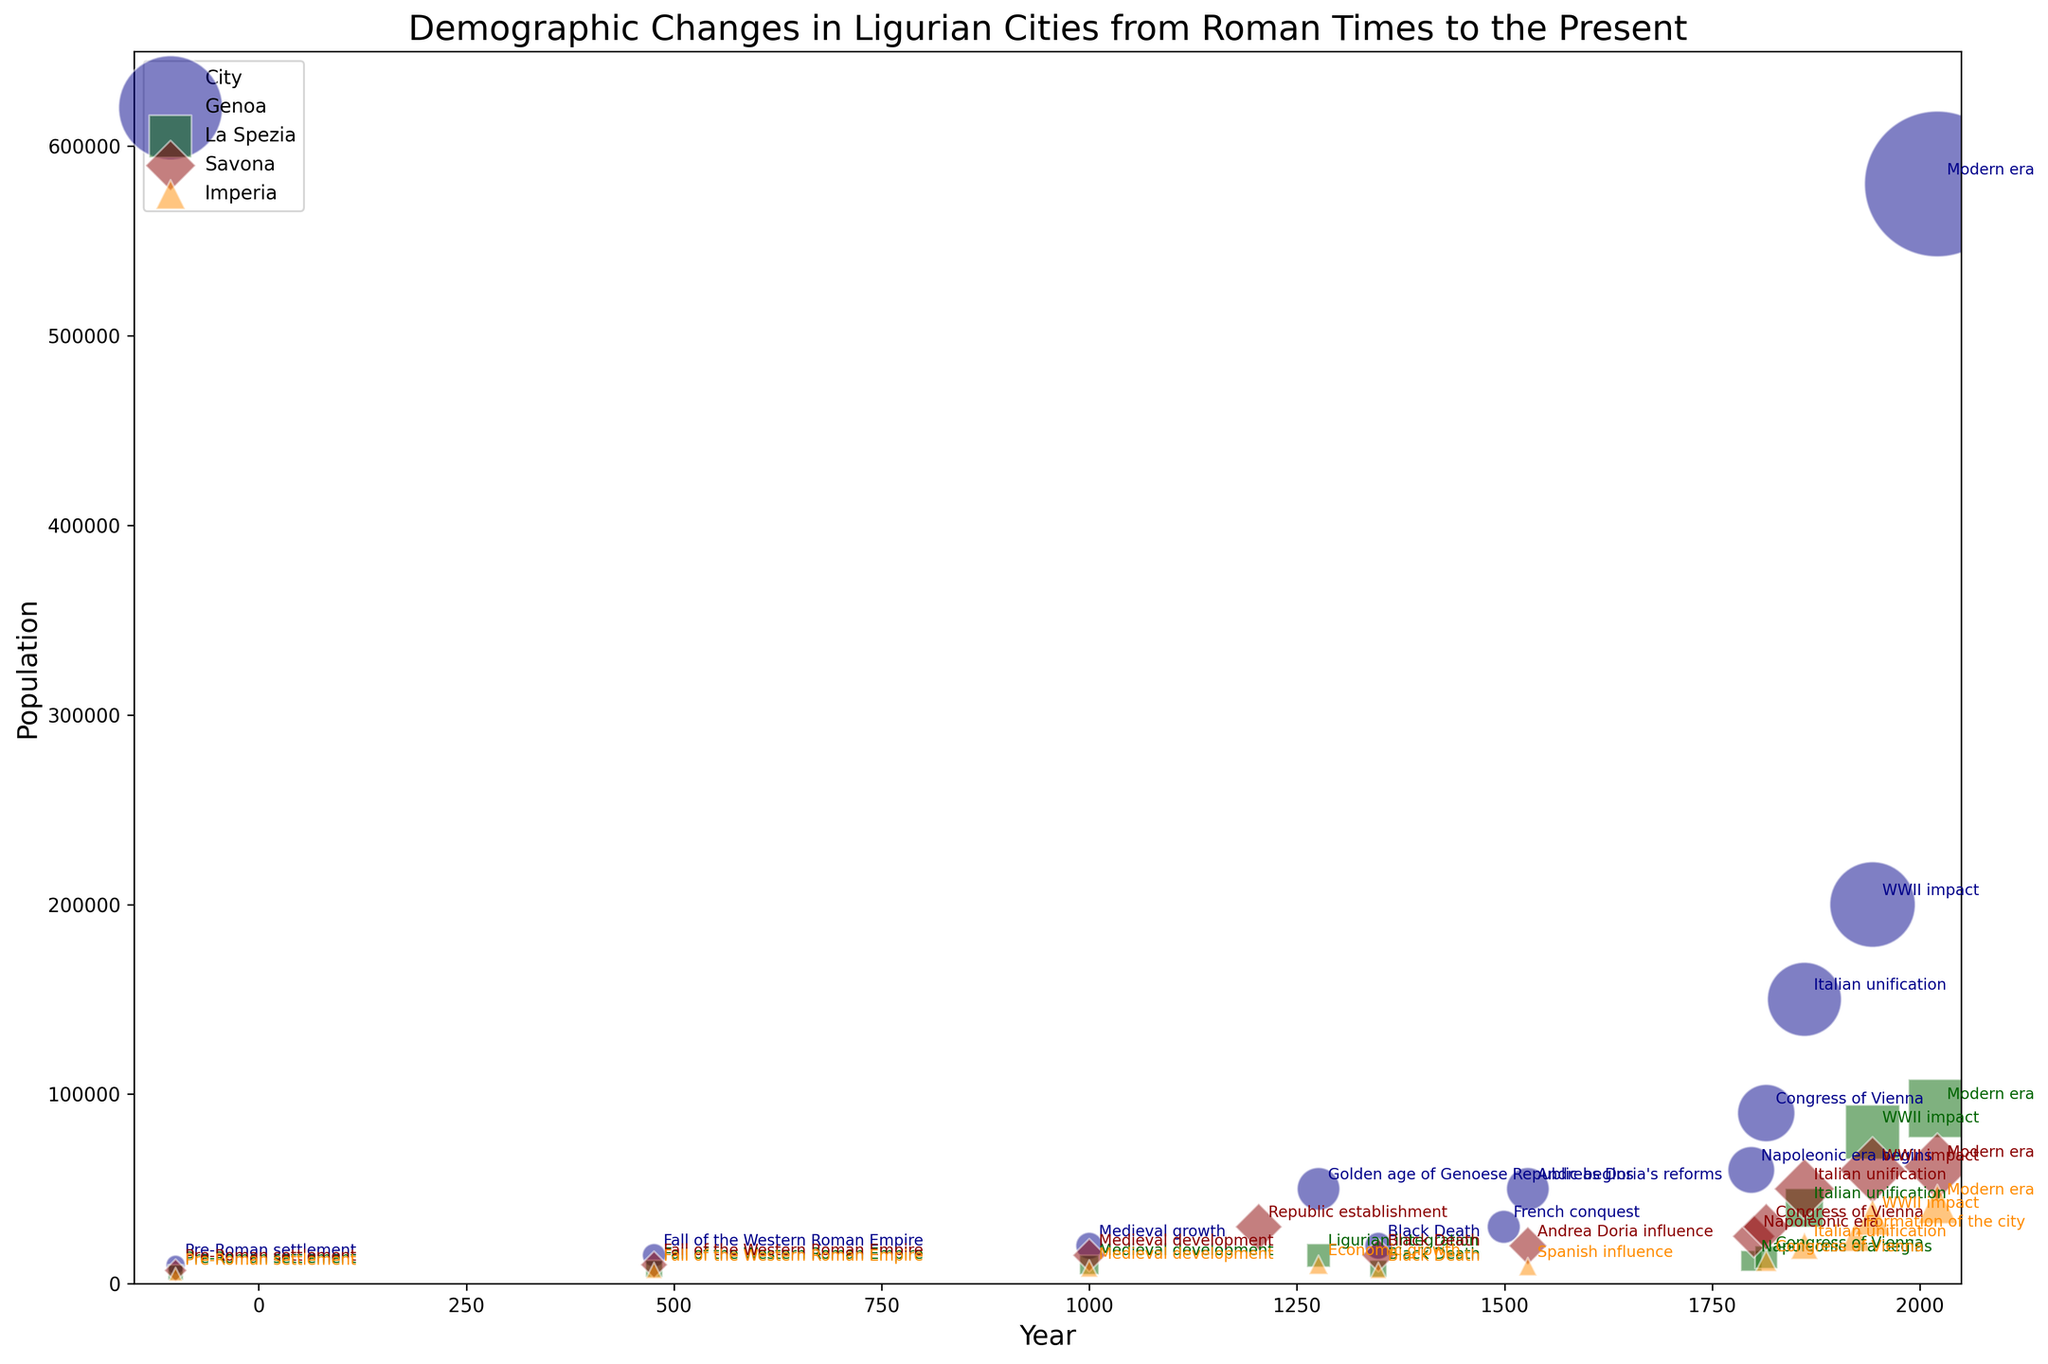What is the population difference between Genoa and La Spezia in 2021? The population of Genoa in 2021 is 580,097, and the population of La Spezia in 2021 is 92,480. Subtract the population of La Spezia from Genoa's population to find the difference: 580,097 - 92,480 = 487,617.
Answer: 487,617 Which city experienced the most significant population decline due to the Black Death in 1348? Compare the population before and after the Black Death for each city. The populations are: 
- Genoa: 50,000 to 20,000 (decline of 30,000) 
- La Spezia: 15,000 to 8,000 (decline of 7,000)
- Savona: 30,000 to 15,000 (decline of 15,000) 
- Imperia: 10,000 to 7,000 (decline of 3,000) 
The most significant decline is in Genoa with 30,000.
Answer: Genoa How did the population of Savona change from the Congress of Vienna in 1815 to the Italian unification in 1861? The population of Savona in 1815 was 30,000, and in 1861 it was 50,000. To find the change, subtract the 1815 population from the 1861 population: 50,000 - 30,000 = 20,000.
Answer: Increased by 20,000 Which city had the largest population during the Napoleonic Era Begins in 1797? The populations in 1797 are: 
- Genoa: 60,000,
- La Spezia: 12,000,
- Savona: 25,000. 
- Imperia is not specified for 1797. The city with the largest population is Genoa with 60,000.
Answer: Genoa Compare the population growth of Genoa and Imperia from their respective pre-Roman settlements to 2021. Which city grew more? In -100, populations were:
- Genoa: 10,000, 
- Imperia: 5,000. 
In 2021, populations were:
- Genoa: 580,097, 
- Imperia: 41,997. 
Calculate the growth:
- Genoa: 580,097 - 10,000 = 570,097
- Imperia: 41,997 - 5,000 = 36,997
Genoa grew more by 570,097 – 36,997 = 533,100.
Answer: Genoa In which year did Genoa and Savona both have a population of 50,000? According to the chart:
- Genoa had a population of 50,000 in both 1276 and 1528.
- Savona had a population of 50,000 in 1861.
The only matching year between the two is 1528.
Answer: 1528 